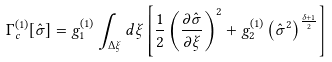Convert formula to latex. <formula><loc_0><loc_0><loc_500><loc_500>\Gamma _ { c } ^ { ( 1 ) } [ \hat { \sigma } ] = g _ { 1 } ^ { ( 1 ) } \int _ { \Delta \xi } d \xi \left [ \frac { 1 } { 2 } \left ( \frac { \partial \hat { \sigma } } { \partial \xi } \right ) ^ { 2 } + g _ { 2 } ^ { ( 1 ) } \left ( \hat { \sigma } ^ { 2 } \right ) ^ { \frac { \delta + 1 } { 2 } } \right ]</formula> 